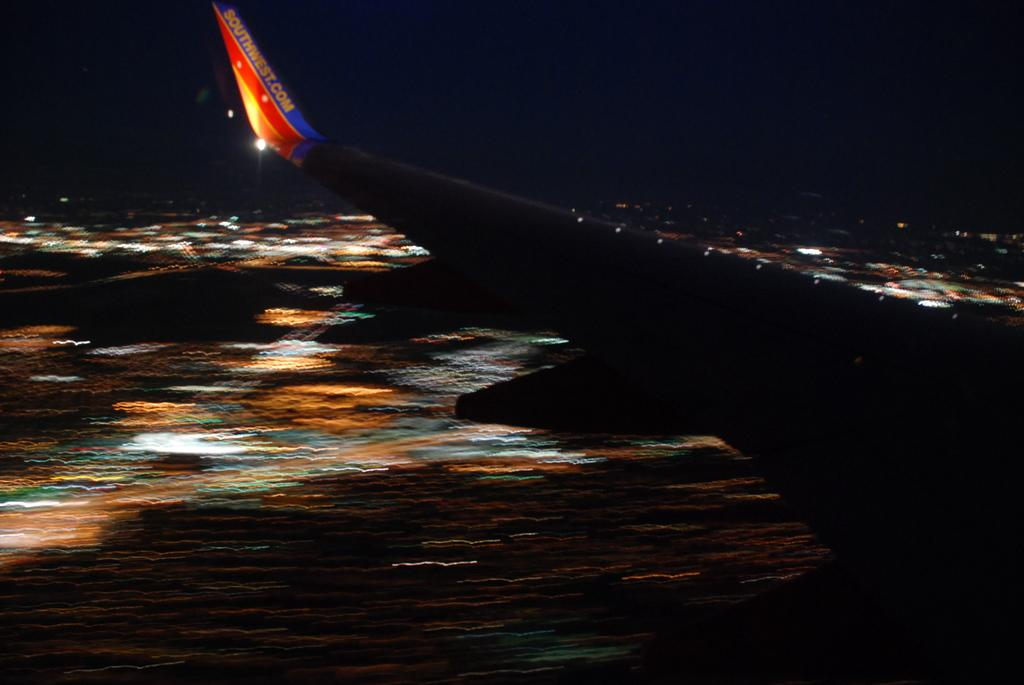<image>
Describe the image concisely. a blurred landing of a Southwest flight where only the wing is visible 